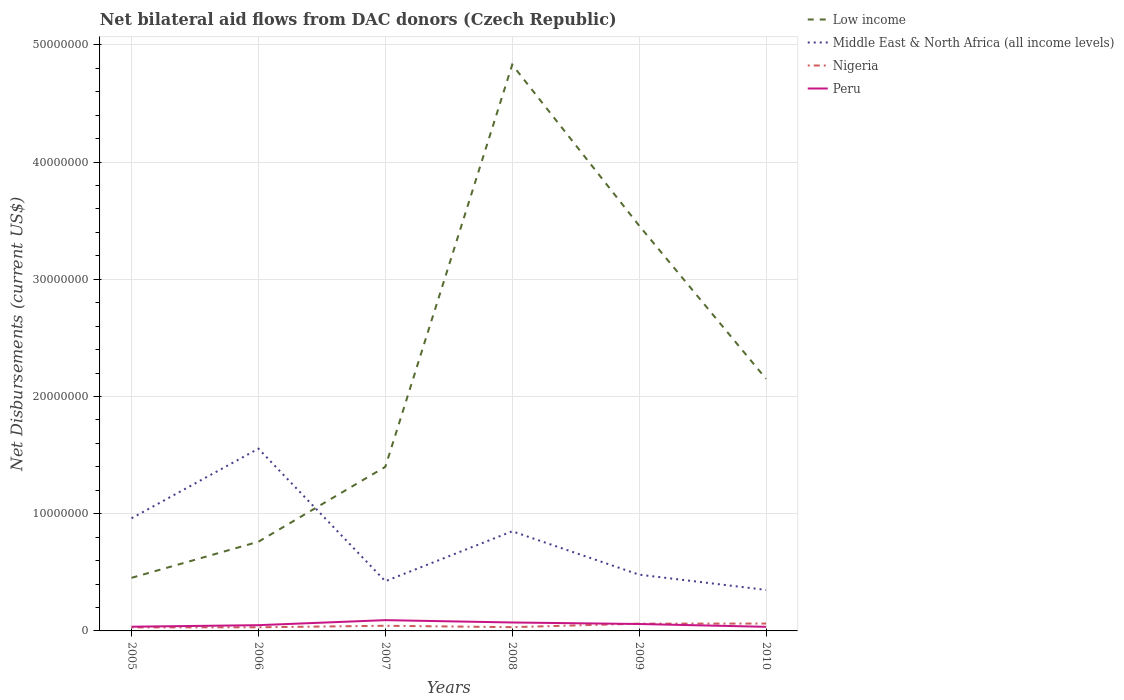How many different coloured lines are there?
Make the answer very short. 4. Is the number of lines equal to the number of legend labels?
Offer a terse response. Yes. Across all years, what is the maximum net bilateral aid flows in Middle East & North Africa (all income levels)?
Provide a short and direct response. 3.50e+06. In which year was the net bilateral aid flows in Peru maximum?
Your response must be concise. 2010. What is the total net bilateral aid flows in Peru in the graph?
Give a very brief answer. 5.70e+05. What is the difference between the highest and the second highest net bilateral aid flows in Low income?
Keep it short and to the point. 4.38e+07. What is the difference between the highest and the lowest net bilateral aid flows in Middle East & North Africa (all income levels)?
Provide a short and direct response. 3. Is the net bilateral aid flows in Peru strictly greater than the net bilateral aid flows in Nigeria over the years?
Offer a very short reply. No. Are the values on the major ticks of Y-axis written in scientific E-notation?
Your answer should be very brief. No. How many legend labels are there?
Ensure brevity in your answer.  4. How are the legend labels stacked?
Your response must be concise. Vertical. What is the title of the graph?
Offer a terse response. Net bilateral aid flows from DAC donors (Czech Republic). What is the label or title of the X-axis?
Provide a short and direct response. Years. What is the label or title of the Y-axis?
Your answer should be compact. Net Disbursements (current US$). What is the Net Disbursements (current US$) of Low income in 2005?
Offer a very short reply. 4.53e+06. What is the Net Disbursements (current US$) of Middle East & North Africa (all income levels) in 2005?
Make the answer very short. 9.61e+06. What is the Net Disbursements (current US$) in Peru in 2005?
Provide a short and direct response. 3.60e+05. What is the Net Disbursements (current US$) in Low income in 2006?
Provide a short and direct response. 7.61e+06. What is the Net Disbursements (current US$) of Middle East & North Africa (all income levels) in 2006?
Provide a succinct answer. 1.56e+07. What is the Net Disbursements (current US$) in Peru in 2006?
Offer a terse response. 4.90e+05. What is the Net Disbursements (current US$) of Low income in 2007?
Your answer should be compact. 1.40e+07. What is the Net Disbursements (current US$) of Middle East & North Africa (all income levels) in 2007?
Give a very brief answer. 4.24e+06. What is the Net Disbursements (current US$) in Nigeria in 2007?
Provide a succinct answer. 4.40e+05. What is the Net Disbursements (current US$) in Peru in 2007?
Your answer should be very brief. 9.20e+05. What is the Net Disbursements (current US$) of Low income in 2008?
Provide a short and direct response. 4.83e+07. What is the Net Disbursements (current US$) of Middle East & North Africa (all income levels) in 2008?
Offer a very short reply. 8.50e+06. What is the Net Disbursements (current US$) in Nigeria in 2008?
Keep it short and to the point. 3.20e+05. What is the Net Disbursements (current US$) in Peru in 2008?
Your response must be concise. 7.20e+05. What is the Net Disbursements (current US$) of Low income in 2009?
Provide a succinct answer. 3.46e+07. What is the Net Disbursements (current US$) in Middle East & North Africa (all income levels) in 2009?
Make the answer very short. 4.80e+06. What is the Net Disbursements (current US$) in Nigeria in 2009?
Offer a terse response. 6.20e+05. What is the Net Disbursements (current US$) in Peru in 2009?
Your answer should be compact. 5.90e+05. What is the Net Disbursements (current US$) in Low income in 2010?
Ensure brevity in your answer.  2.15e+07. What is the Net Disbursements (current US$) in Middle East & North Africa (all income levels) in 2010?
Your answer should be very brief. 3.50e+06. What is the Net Disbursements (current US$) in Nigeria in 2010?
Give a very brief answer. 6.30e+05. Across all years, what is the maximum Net Disbursements (current US$) of Low income?
Provide a short and direct response. 4.83e+07. Across all years, what is the maximum Net Disbursements (current US$) in Middle East & North Africa (all income levels)?
Your response must be concise. 1.56e+07. Across all years, what is the maximum Net Disbursements (current US$) in Nigeria?
Offer a terse response. 6.30e+05. Across all years, what is the maximum Net Disbursements (current US$) of Peru?
Your response must be concise. 9.20e+05. Across all years, what is the minimum Net Disbursements (current US$) of Low income?
Give a very brief answer. 4.53e+06. Across all years, what is the minimum Net Disbursements (current US$) of Middle East & North Africa (all income levels)?
Offer a very short reply. 3.50e+06. Across all years, what is the minimum Net Disbursements (current US$) of Nigeria?
Offer a terse response. 3.00e+05. Across all years, what is the minimum Net Disbursements (current US$) in Peru?
Keep it short and to the point. 3.50e+05. What is the total Net Disbursements (current US$) in Low income in the graph?
Your response must be concise. 1.31e+08. What is the total Net Disbursements (current US$) in Middle East & North Africa (all income levels) in the graph?
Your response must be concise. 4.62e+07. What is the total Net Disbursements (current US$) of Nigeria in the graph?
Provide a succinct answer. 2.62e+06. What is the total Net Disbursements (current US$) in Peru in the graph?
Provide a short and direct response. 3.43e+06. What is the difference between the Net Disbursements (current US$) in Low income in 2005 and that in 2006?
Provide a succinct answer. -3.08e+06. What is the difference between the Net Disbursements (current US$) in Middle East & North Africa (all income levels) in 2005 and that in 2006?
Make the answer very short. -5.94e+06. What is the difference between the Net Disbursements (current US$) in Nigeria in 2005 and that in 2006?
Make the answer very short. -10000. What is the difference between the Net Disbursements (current US$) in Low income in 2005 and that in 2007?
Offer a terse response. -9.47e+06. What is the difference between the Net Disbursements (current US$) of Middle East & North Africa (all income levels) in 2005 and that in 2007?
Make the answer very short. 5.37e+06. What is the difference between the Net Disbursements (current US$) of Peru in 2005 and that in 2007?
Provide a succinct answer. -5.60e+05. What is the difference between the Net Disbursements (current US$) of Low income in 2005 and that in 2008?
Give a very brief answer. -4.38e+07. What is the difference between the Net Disbursements (current US$) of Middle East & North Africa (all income levels) in 2005 and that in 2008?
Your response must be concise. 1.11e+06. What is the difference between the Net Disbursements (current US$) in Nigeria in 2005 and that in 2008?
Make the answer very short. -2.00e+04. What is the difference between the Net Disbursements (current US$) of Peru in 2005 and that in 2008?
Make the answer very short. -3.60e+05. What is the difference between the Net Disbursements (current US$) in Low income in 2005 and that in 2009?
Your answer should be compact. -3.00e+07. What is the difference between the Net Disbursements (current US$) of Middle East & North Africa (all income levels) in 2005 and that in 2009?
Your answer should be compact. 4.81e+06. What is the difference between the Net Disbursements (current US$) in Nigeria in 2005 and that in 2009?
Provide a succinct answer. -3.20e+05. What is the difference between the Net Disbursements (current US$) of Peru in 2005 and that in 2009?
Offer a terse response. -2.30e+05. What is the difference between the Net Disbursements (current US$) in Low income in 2005 and that in 2010?
Give a very brief answer. -1.70e+07. What is the difference between the Net Disbursements (current US$) of Middle East & North Africa (all income levels) in 2005 and that in 2010?
Ensure brevity in your answer.  6.11e+06. What is the difference between the Net Disbursements (current US$) of Nigeria in 2005 and that in 2010?
Offer a very short reply. -3.30e+05. What is the difference between the Net Disbursements (current US$) of Low income in 2006 and that in 2007?
Your answer should be very brief. -6.39e+06. What is the difference between the Net Disbursements (current US$) of Middle East & North Africa (all income levels) in 2006 and that in 2007?
Your answer should be very brief. 1.13e+07. What is the difference between the Net Disbursements (current US$) in Peru in 2006 and that in 2007?
Make the answer very short. -4.30e+05. What is the difference between the Net Disbursements (current US$) of Low income in 2006 and that in 2008?
Provide a short and direct response. -4.07e+07. What is the difference between the Net Disbursements (current US$) in Middle East & North Africa (all income levels) in 2006 and that in 2008?
Give a very brief answer. 7.05e+06. What is the difference between the Net Disbursements (current US$) in Nigeria in 2006 and that in 2008?
Give a very brief answer. -10000. What is the difference between the Net Disbursements (current US$) in Peru in 2006 and that in 2008?
Your answer should be very brief. -2.30e+05. What is the difference between the Net Disbursements (current US$) of Low income in 2006 and that in 2009?
Offer a very short reply. -2.70e+07. What is the difference between the Net Disbursements (current US$) of Middle East & North Africa (all income levels) in 2006 and that in 2009?
Your answer should be compact. 1.08e+07. What is the difference between the Net Disbursements (current US$) of Nigeria in 2006 and that in 2009?
Give a very brief answer. -3.10e+05. What is the difference between the Net Disbursements (current US$) in Peru in 2006 and that in 2009?
Give a very brief answer. -1.00e+05. What is the difference between the Net Disbursements (current US$) of Low income in 2006 and that in 2010?
Offer a terse response. -1.39e+07. What is the difference between the Net Disbursements (current US$) of Middle East & North Africa (all income levels) in 2006 and that in 2010?
Ensure brevity in your answer.  1.20e+07. What is the difference between the Net Disbursements (current US$) in Nigeria in 2006 and that in 2010?
Offer a terse response. -3.20e+05. What is the difference between the Net Disbursements (current US$) in Peru in 2006 and that in 2010?
Give a very brief answer. 1.40e+05. What is the difference between the Net Disbursements (current US$) of Low income in 2007 and that in 2008?
Offer a terse response. -3.43e+07. What is the difference between the Net Disbursements (current US$) of Middle East & North Africa (all income levels) in 2007 and that in 2008?
Your answer should be compact. -4.26e+06. What is the difference between the Net Disbursements (current US$) of Peru in 2007 and that in 2008?
Provide a succinct answer. 2.00e+05. What is the difference between the Net Disbursements (current US$) of Low income in 2007 and that in 2009?
Your answer should be compact. -2.06e+07. What is the difference between the Net Disbursements (current US$) of Middle East & North Africa (all income levels) in 2007 and that in 2009?
Keep it short and to the point. -5.60e+05. What is the difference between the Net Disbursements (current US$) of Low income in 2007 and that in 2010?
Your response must be concise. -7.51e+06. What is the difference between the Net Disbursements (current US$) in Middle East & North Africa (all income levels) in 2007 and that in 2010?
Give a very brief answer. 7.40e+05. What is the difference between the Net Disbursements (current US$) of Peru in 2007 and that in 2010?
Your answer should be very brief. 5.70e+05. What is the difference between the Net Disbursements (current US$) of Low income in 2008 and that in 2009?
Give a very brief answer. 1.37e+07. What is the difference between the Net Disbursements (current US$) of Middle East & North Africa (all income levels) in 2008 and that in 2009?
Provide a short and direct response. 3.70e+06. What is the difference between the Net Disbursements (current US$) in Peru in 2008 and that in 2009?
Provide a short and direct response. 1.30e+05. What is the difference between the Net Disbursements (current US$) of Low income in 2008 and that in 2010?
Your response must be concise. 2.68e+07. What is the difference between the Net Disbursements (current US$) of Nigeria in 2008 and that in 2010?
Offer a terse response. -3.10e+05. What is the difference between the Net Disbursements (current US$) of Low income in 2009 and that in 2010?
Provide a short and direct response. 1.31e+07. What is the difference between the Net Disbursements (current US$) in Middle East & North Africa (all income levels) in 2009 and that in 2010?
Your answer should be very brief. 1.30e+06. What is the difference between the Net Disbursements (current US$) in Nigeria in 2009 and that in 2010?
Give a very brief answer. -10000. What is the difference between the Net Disbursements (current US$) of Low income in 2005 and the Net Disbursements (current US$) of Middle East & North Africa (all income levels) in 2006?
Provide a succinct answer. -1.10e+07. What is the difference between the Net Disbursements (current US$) of Low income in 2005 and the Net Disbursements (current US$) of Nigeria in 2006?
Provide a succinct answer. 4.22e+06. What is the difference between the Net Disbursements (current US$) of Low income in 2005 and the Net Disbursements (current US$) of Peru in 2006?
Offer a terse response. 4.04e+06. What is the difference between the Net Disbursements (current US$) of Middle East & North Africa (all income levels) in 2005 and the Net Disbursements (current US$) of Nigeria in 2006?
Offer a terse response. 9.30e+06. What is the difference between the Net Disbursements (current US$) in Middle East & North Africa (all income levels) in 2005 and the Net Disbursements (current US$) in Peru in 2006?
Ensure brevity in your answer.  9.12e+06. What is the difference between the Net Disbursements (current US$) of Low income in 2005 and the Net Disbursements (current US$) of Nigeria in 2007?
Give a very brief answer. 4.09e+06. What is the difference between the Net Disbursements (current US$) in Low income in 2005 and the Net Disbursements (current US$) in Peru in 2007?
Keep it short and to the point. 3.61e+06. What is the difference between the Net Disbursements (current US$) in Middle East & North Africa (all income levels) in 2005 and the Net Disbursements (current US$) in Nigeria in 2007?
Keep it short and to the point. 9.17e+06. What is the difference between the Net Disbursements (current US$) of Middle East & North Africa (all income levels) in 2005 and the Net Disbursements (current US$) of Peru in 2007?
Your answer should be very brief. 8.69e+06. What is the difference between the Net Disbursements (current US$) in Nigeria in 2005 and the Net Disbursements (current US$) in Peru in 2007?
Your response must be concise. -6.20e+05. What is the difference between the Net Disbursements (current US$) in Low income in 2005 and the Net Disbursements (current US$) in Middle East & North Africa (all income levels) in 2008?
Make the answer very short. -3.97e+06. What is the difference between the Net Disbursements (current US$) in Low income in 2005 and the Net Disbursements (current US$) in Nigeria in 2008?
Offer a very short reply. 4.21e+06. What is the difference between the Net Disbursements (current US$) of Low income in 2005 and the Net Disbursements (current US$) of Peru in 2008?
Your answer should be compact. 3.81e+06. What is the difference between the Net Disbursements (current US$) of Middle East & North Africa (all income levels) in 2005 and the Net Disbursements (current US$) of Nigeria in 2008?
Make the answer very short. 9.29e+06. What is the difference between the Net Disbursements (current US$) in Middle East & North Africa (all income levels) in 2005 and the Net Disbursements (current US$) in Peru in 2008?
Keep it short and to the point. 8.89e+06. What is the difference between the Net Disbursements (current US$) of Nigeria in 2005 and the Net Disbursements (current US$) of Peru in 2008?
Provide a short and direct response. -4.20e+05. What is the difference between the Net Disbursements (current US$) in Low income in 2005 and the Net Disbursements (current US$) in Nigeria in 2009?
Ensure brevity in your answer.  3.91e+06. What is the difference between the Net Disbursements (current US$) of Low income in 2005 and the Net Disbursements (current US$) of Peru in 2009?
Offer a terse response. 3.94e+06. What is the difference between the Net Disbursements (current US$) in Middle East & North Africa (all income levels) in 2005 and the Net Disbursements (current US$) in Nigeria in 2009?
Provide a succinct answer. 8.99e+06. What is the difference between the Net Disbursements (current US$) in Middle East & North Africa (all income levels) in 2005 and the Net Disbursements (current US$) in Peru in 2009?
Make the answer very short. 9.02e+06. What is the difference between the Net Disbursements (current US$) of Low income in 2005 and the Net Disbursements (current US$) of Middle East & North Africa (all income levels) in 2010?
Provide a short and direct response. 1.03e+06. What is the difference between the Net Disbursements (current US$) of Low income in 2005 and the Net Disbursements (current US$) of Nigeria in 2010?
Provide a short and direct response. 3.90e+06. What is the difference between the Net Disbursements (current US$) of Low income in 2005 and the Net Disbursements (current US$) of Peru in 2010?
Your answer should be very brief. 4.18e+06. What is the difference between the Net Disbursements (current US$) in Middle East & North Africa (all income levels) in 2005 and the Net Disbursements (current US$) in Nigeria in 2010?
Offer a very short reply. 8.98e+06. What is the difference between the Net Disbursements (current US$) of Middle East & North Africa (all income levels) in 2005 and the Net Disbursements (current US$) of Peru in 2010?
Give a very brief answer. 9.26e+06. What is the difference between the Net Disbursements (current US$) in Nigeria in 2005 and the Net Disbursements (current US$) in Peru in 2010?
Make the answer very short. -5.00e+04. What is the difference between the Net Disbursements (current US$) in Low income in 2006 and the Net Disbursements (current US$) in Middle East & North Africa (all income levels) in 2007?
Your answer should be very brief. 3.37e+06. What is the difference between the Net Disbursements (current US$) in Low income in 2006 and the Net Disbursements (current US$) in Nigeria in 2007?
Your answer should be very brief. 7.17e+06. What is the difference between the Net Disbursements (current US$) in Low income in 2006 and the Net Disbursements (current US$) in Peru in 2007?
Ensure brevity in your answer.  6.69e+06. What is the difference between the Net Disbursements (current US$) in Middle East & North Africa (all income levels) in 2006 and the Net Disbursements (current US$) in Nigeria in 2007?
Offer a very short reply. 1.51e+07. What is the difference between the Net Disbursements (current US$) in Middle East & North Africa (all income levels) in 2006 and the Net Disbursements (current US$) in Peru in 2007?
Make the answer very short. 1.46e+07. What is the difference between the Net Disbursements (current US$) in Nigeria in 2006 and the Net Disbursements (current US$) in Peru in 2007?
Make the answer very short. -6.10e+05. What is the difference between the Net Disbursements (current US$) in Low income in 2006 and the Net Disbursements (current US$) in Middle East & North Africa (all income levels) in 2008?
Provide a succinct answer. -8.90e+05. What is the difference between the Net Disbursements (current US$) in Low income in 2006 and the Net Disbursements (current US$) in Nigeria in 2008?
Offer a very short reply. 7.29e+06. What is the difference between the Net Disbursements (current US$) in Low income in 2006 and the Net Disbursements (current US$) in Peru in 2008?
Your answer should be compact. 6.89e+06. What is the difference between the Net Disbursements (current US$) of Middle East & North Africa (all income levels) in 2006 and the Net Disbursements (current US$) of Nigeria in 2008?
Make the answer very short. 1.52e+07. What is the difference between the Net Disbursements (current US$) of Middle East & North Africa (all income levels) in 2006 and the Net Disbursements (current US$) of Peru in 2008?
Your answer should be compact. 1.48e+07. What is the difference between the Net Disbursements (current US$) of Nigeria in 2006 and the Net Disbursements (current US$) of Peru in 2008?
Offer a very short reply. -4.10e+05. What is the difference between the Net Disbursements (current US$) in Low income in 2006 and the Net Disbursements (current US$) in Middle East & North Africa (all income levels) in 2009?
Your answer should be very brief. 2.81e+06. What is the difference between the Net Disbursements (current US$) of Low income in 2006 and the Net Disbursements (current US$) of Nigeria in 2009?
Your response must be concise. 6.99e+06. What is the difference between the Net Disbursements (current US$) in Low income in 2006 and the Net Disbursements (current US$) in Peru in 2009?
Provide a succinct answer. 7.02e+06. What is the difference between the Net Disbursements (current US$) of Middle East & North Africa (all income levels) in 2006 and the Net Disbursements (current US$) of Nigeria in 2009?
Provide a succinct answer. 1.49e+07. What is the difference between the Net Disbursements (current US$) of Middle East & North Africa (all income levels) in 2006 and the Net Disbursements (current US$) of Peru in 2009?
Provide a short and direct response. 1.50e+07. What is the difference between the Net Disbursements (current US$) in Nigeria in 2006 and the Net Disbursements (current US$) in Peru in 2009?
Keep it short and to the point. -2.80e+05. What is the difference between the Net Disbursements (current US$) in Low income in 2006 and the Net Disbursements (current US$) in Middle East & North Africa (all income levels) in 2010?
Provide a short and direct response. 4.11e+06. What is the difference between the Net Disbursements (current US$) in Low income in 2006 and the Net Disbursements (current US$) in Nigeria in 2010?
Your response must be concise. 6.98e+06. What is the difference between the Net Disbursements (current US$) in Low income in 2006 and the Net Disbursements (current US$) in Peru in 2010?
Keep it short and to the point. 7.26e+06. What is the difference between the Net Disbursements (current US$) in Middle East & North Africa (all income levels) in 2006 and the Net Disbursements (current US$) in Nigeria in 2010?
Your response must be concise. 1.49e+07. What is the difference between the Net Disbursements (current US$) in Middle East & North Africa (all income levels) in 2006 and the Net Disbursements (current US$) in Peru in 2010?
Your response must be concise. 1.52e+07. What is the difference between the Net Disbursements (current US$) in Low income in 2007 and the Net Disbursements (current US$) in Middle East & North Africa (all income levels) in 2008?
Your answer should be very brief. 5.50e+06. What is the difference between the Net Disbursements (current US$) in Low income in 2007 and the Net Disbursements (current US$) in Nigeria in 2008?
Make the answer very short. 1.37e+07. What is the difference between the Net Disbursements (current US$) in Low income in 2007 and the Net Disbursements (current US$) in Peru in 2008?
Provide a succinct answer. 1.33e+07. What is the difference between the Net Disbursements (current US$) in Middle East & North Africa (all income levels) in 2007 and the Net Disbursements (current US$) in Nigeria in 2008?
Your response must be concise. 3.92e+06. What is the difference between the Net Disbursements (current US$) of Middle East & North Africa (all income levels) in 2007 and the Net Disbursements (current US$) of Peru in 2008?
Your response must be concise. 3.52e+06. What is the difference between the Net Disbursements (current US$) in Nigeria in 2007 and the Net Disbursements (current US$) in Peru in 2008?
Your answer should be very brief. -2.80e+05. What is the difference between the Net Disbursements (current US$) in Low income in 2007 and the Net Disbursements (current US$) in Middle East & North Africa (all income levels) in 2009?
Keep it short and to the point. 9.20e+06. What is the difference between the Net Disbursements (current US$) of Low income in 2007 and the Net Disbursements (current US$) of Nigeria in 2009?
Your response must be concise. 1.34e+07. What is the difference between the Net Disbursements (current US$) of Low income in 2007 and the Net Disbursements (current US$) of Peru in 2009?
Ensure brevity in your answer.  1.34e+07. What is the difference between the Net Disbursements (current US$) of Middle East & North Africa (all income levels) in 2007 and the Net Disbursements (current US$) of Nigeria in 2009?
Provide a short and direct response. 3.62e+06. What is the difference between the Net Disbursements (current US$) in Middle East & North Africa (all income levels) in 2007 and the Net Disbursements (current US$) in Peru in 2009?
Your answer should be compact. 3.65e+06. What is the difference between the Net Disbursements (current US$) in Nigeria in 2007 and the Net Disbursements (current US$) in Peru in 2009?
Keep it short and to the point. -1.50e+05. What is the difference between the Net Disbursements (current US$) in Low income in 2007 and the Net Disbursements (current US$) in Middle East & North Africa (all income levels) in 2010?
Your response must be concise. 1.05e+07. What is the difference between the Net Disbursements (current US$) of Low income in 2007 and the Net Disbursements (current US$) of Nigeria in 2010?
Your answer should be very brief. 1.34e+07. What is the difference between the Net Disbursements (current US$) of Low income in 2007 and the Net Disbursements (current US$) of Peru in 2010?
Make the answer very short. 1.36e+07. What is the difference between the Net Disbursements (current US$) of Middle East & North Africa (all income levels) in 2007 and the Net Disbursements (current US$) of Nigeria in 2010?
Make the answer very short. 3.61e+06. What is the difference between the Net Disbursements (current US$) of Middle East & North Africa (all income levels) in 2007 and the Net Disbursements (current US$) of Peru in 2010?
Provide a short and direct response. 3.89e+06. What is the difference between the Net Disbursements (current US$) in Nigeria in 2007 and the Net Disbursements (current US$) in Peru in 2010?
Offer a terse response. 9.00e+04. What is the difference between the Net Disbursements (current US$) of Low income in 2008 and the Net Disbursements (current US$) of Middle East & North Africa (all income levels) in 2009?
Provide a short and direct response. 4.35e+07. What is the difference between the Net Disbursements (current US$) in Low income in 2008 and the Net Disbursements (current US$) in Nigeria in 2009?
Keep it short and to the point. 4.77e+07. What is the difference between the Net Disbursements (current US$) of Low income in 2008 and the Net Disbursements (current US$) of Peru in 2009?
Give a very brief answer. 4.77e+07. What is the difference between the Net Disbursements (current US$) in Middle East & North Africa (all income levels) in 2008 and the Net Disbursements (current US$) in Nigeria in 2009?
Your response must be concise. 7.88e+06. What is the difference between the Net Disbursements (current US$) of Middle East & North Africa (all income levels) in 2008 and the Net Disbursements (current US$) of Peru in 2009?
Your answer should be compact. 7.91e+06. What is the difference between the Net Disbursements (current US$) in Nigeria in 2008 and the Net Disbursements (current US$) in Peru in 2009?
Give a very brief answer. -2.70e+05. What is the difference between the Net Disbursements (current US$) in Low income in 2008 and the Net Disbursements (current US$) in Middle East & North Africa (all income levels) in 2010?
Your response must be concise. 4.48e+07. What is the difference between the Net Disbursements (current US$) of Low income in 2008 and the Net Disbursements (current US$) of Nigeria in 2010?
Make the answer very short. 4.77e+07. What is the difference between the Net Disbursements (current US$) of Low income in 2008 and the Net Disbursements (current US$) of Peru in 2010?
Offer a terse response. 4.80e+07. What is the difference between the Net Disbursements (current US$) in Middle East & North Africa (all income levels) in 2008 and the Net Disbursements (current US$) in Nigeria in 2010?
Keep it short and to the point. 7.87e+06. What is the difference between the Net Disbursements (current US$) of Middle East & North Africa (all income levels) in 2008 and the Net Disbursements (current US$) of Peru in 2010?
Your response must be concise. 8.15e+06. What is the difference between the Net Disbursements (current US$) of Low income in 2009 and the Net Disbursements (current US$) of Middle East & North Africa (all income levels) in 2010?
Provide a short and direct response. 3.11e+07. What is the difference between the Net Disbursements (current US$) in Low income in 2009 and the Net Disbursements (current US$) in Nigeria in 2010?
Give a very brief answer. 3.40e+07. What is the difference between the Net Disbursements (current US$) of Low income in 2009 and the Net Disbursements (current US$) of Peru in 2010?
Keep it short and to the point. 3.42e+07. What is the difference between the Net Disbursements (current US$) of Middle East & North Africa (all income levels) in 2009 and the Net Disbursements (current US$) of Nigeria in 2010?
Provide a short and direct response. 4.17e+06. What is the difference between the Net Disbursements (current US$) of Middle East & North Africa (all income levels) in 2009 and the Net Disbursements (current US$) of Peru in 2010?
Give a very brief answer. 4.45e+06. What is the average Net Disbursements (current US$) in Low income per year?
Ensure brevity in your answer.  2.18e+07. What is the average Net Disbursements (current US$) in Middle East & North Africa (all income levels) per year?
Offer a very short reply. 7.70e+06. What is the average Net Disbursements (current US$) in Nigeria per year?
Keep it short and to the point. 4.37e+05. What is the average Net Disbursements (current US$) in Peru per year?
Ensure brevity in your answer.  5.72e+05. In the year 2005, what is the difference between the Net Disbursements (current US$) of Low income and Net Disbursements (current US$) of Middle East & North Africa (all income levels)?
Keep it short and to the point. -5.08e+06. In the year 2005, what is the difference between the Net Disbursements (current US$) in Low income and Net Disbursements (current US$) in Nigeria?
Offer a terse response. 4.23e+06. In the year 2005, what is the difference between the Net Disbursements (current US$) in Low income and Net Disbursements (current US$) in Peru?
Provide a short and direct response. 4.17e+06. In the year 2005, what is the difference between the Net Disbursements (current US$) of Middle East & North Africa (all income levels) and Net Disbursements (current US$) of Nigeria?
Provide a succinct answer. 9.31e+06. In the year 2005, what is the difference between the Net Disbursements (current US$) in Middle East & North Africa (all income levels) and Net Disbursements (current US$) in Peru?
Your answer should be compact. 9.25e+06. In the year 2005, what is the difference between the Net Disbursements (current US$) in Nigeria and Net Disbursements (current US$) in Peru?
Give a very brief answer. -6.00e+04. In the year 2006, what is the difference between the Net Disbursements (current US$) of Low income and Net Disbursements (current US$) of Middle East & North Africa (all income levels)?
Provide a short and direct response. -7.94e+06. In the year 2006, what is the difference between the Net Disbursements (current US$) in Low income and Net Disbursements (current US$) in Nigeria?
Make the answer very short. 7.30e+06. In the year 2006, what is the difference between the Net Disbursements (current US$) in Low income and Net Disbursements (current US$) in Peru?
Offer a very short reply. 7.12e+06. In the year 2006, what is the difference between the Net Disbursements (current US$) in Middle East & North Africa (all income levels) and Net Disbursements (current US$) in Nigeria?
Provide a short and direct response. 1.52e+07. In the year 2006, what is the difference between the Net Disbursements (current US$) in Middle East & North Africa (all income levels) and Net Disbursements (current US$) in Peru?
Give a very brief answer. 1.51e+07. In the year 2007, what is the difference between the Net Disbursements (current US$) of Low income and Net Disbursements (current US$) of Middle East & North Africa (all income levels)?
Offer a very short reply. 9.76e+06. In the year 2007, what is the difference between the Net Disbursements (current US$) in Low income and Net Disbursements (current US$) in Nigeria?
Provide a short and direct response. 1.36e+07. In the year 2007, what is the difference between the Net Disbursements (current US$) of Low income and Net Disbursements (current US$) of Peru?
Make the answer very short. 1.31e+07. In the year 2007, what is the difference between the Net Disbursements (current US$) in Middle East & North Africa (all income levels) and Net Disbursements (current US$) in Nigeria?
Your response must be concise. 3.80e+06. In the year 2007, what is the difference between the Net Disbursements (current US$) in Middle East & North Africa (all income levels) and Net Disbursements (current US$) in Peru?
Your answer should be very brief. 3.32e+06. In the year 2007, what is the difference between the Net Disbursements (current US$) of Nigeria and Net Disbursements (current US$) of Peru?
Offer a terse response. -4.80e+05. In the year 2008, what is the difference between the Net Disbursements (current US$) in Low income and Net Disbursements (current US$) in Middle East & North Africa (all income levels)?
Provide a succinct answer. 3.98e+07. In the year 2008, what is the difference between the Net Disbursements (current US$) in Low income and Net Disbursements (current US$) in Nigeria?
Keep it short and to the point. 4.80e+07. In the year 2008, what is the difference between the Net Disbursements (current US$) of Low income and Net Disbursements (current US$) of Peru?
Your response must be concise. 4.76e+07. In the year 2008, what is the difference between the Net Disbursements (current US$) in Middle East & North Africa (all income levels) and Net Disbursements (current US$) in Nigeria?
Provide a succinct answer. 8.18e+06. In the year 2008, what is the difference between the Net Disbursements (current US$) in Middle East & North Africa (all income levels) and Net Disbursements (current US$) in Peru?
Keep it short and to the point. 7.78e+06. In the year 2008, what is the difference between the Net Disbursements (current US$) in Nigeria and Net Disbursements (current US$) in Peru?
Give a very brief answer. -4.00e+05. In the year 2009, what is the difference between the Net Disbursements (current US$) in Low income and Net Disbursements (current US$) in Middle East & North Africa (all income levels)?
Your answer should be compact. 2.98e+07. In the year 2009, what is the difference between the Net Disbursements (current US$) in Low income and Net Disbursements (current US$) in Nigeria?
Your response must be concise. 3.40e+07. In the year 2009, what is the difference between the Net Disbursements (current US$) in Low income and Net Disbursements (current US$) in Peru?
Keep it short and to the point. 3.40e+07. In the year 2009, what is the difference between the Net Disbursements (current US$) of Middle East & North Africa (all income levels) and Net Disbursements (current US$) of Nigeria?
Your response must be concise. 4.18e+06. In the year 2009, what is the difference between the Net Disbursements (current US$) in Middle East & North Africa (all income levels) and Net Disbursements (current US$) in Peru?
Provide a succinct answer. 4.21e+06. In the year 2010, what is the difference between the Net Disbursements (current US$) of Low income and Net Disbursements (current US$) of Middle East & North Africa (all income levels)?
Provide a succinct answer. 1.80e+07. In the year 2010, what is the difference between the Net Disbursements (current US$) in Low income and Net Disbursements (current US$) in Nigeria?
Offer a terse response. 2.09e+07. In the year 2010, what is the difference between the Net Disbursements (current US$) of Low income and Net Disbursements (current US$) of Peru?
Keep it short and to the point. 2.12e+07. In the year 2010, what is the difference between the Net Disbursements (current US$) of Middle East & North Africa (all income levels) and Net Disbursements (current US$) of Nigeria?
Your answer should be very brief. 2.87e+06. In the year 2010, what is the difference between the Net Disbursements (current US$) of Middle East & North Africa (all income levels) and Net Disbursements (current US$) of Peru?
Ensure brevity in your answer.  3.15e+06. What is the ratio of the Net Disbursements (current US$) of Low income in 2005 to that in 2006?
Make the answer very short. 0.6. What is the ratio of the Net Disbursements (current US$) in Middle East & North Africa (all income levels) in 2005 to that in 2006?
Your response must be concise. 0.62. What is the ratio of the Net Disbursements (current US$) in Peru in 2005 to that in 2006?
Provide a short and direct response. 0.73. What is the ratio of the Net Disbursements (current US$) in Low income in 2005 to that in 2007?
Provide a succinct answer. 0.32. What is the ratio of the Net Disbursements (current US$) of Middle East & North Africa (all income levels) in 2005 to that in 2007?
Offer a very short reply. 2.27. What is the ratio of the Net Disbursements (current US$) of Nigeria in 2005 to that in 2007?
Your response must be concise. 0.68. What is the ratio of the Net Disbursements (current US$) in Peru in 2005 to that in 2007?
Provide a succinct answer. 0.39. What is the ratio of the Net Disbursements (current US$) of Low income in 2005 to that in 2008?
Your answer should be very brief. 0.09. What is the ratio of the Net Disbursements (current US$) of Middle East & North Africa (all income levels) in 2005 to that in 2008?
Provide a succinct answer. 1.13. What is the ratio of the Net Disbursements (current US$) in Low income in 2005 to that in 2009?
Keep it short and to the point. 0.13. What is the ratio of the Net Disbursements (current US$) of Middle East & North Africa (all income levels) in 2005 to that in 2009?
Offer a very short reply. 2. What is the ratio of the Net Disbursements (current US$) of Nigeria in 2005 to that in 2009?
Provide a succinct answer. 0.48. What is the ratio of the Net Disbursements (current US$) in Peru in 2005 to that in 2009?
Offer a very short reply. 0.61. What is the ratio of the Net Disbursements (current US$) of Low income in 2005 to that in 2010?
Your response must be concise. 0.21. What is the ratio of the Net Disbursements (current US$) in Middle East & North Africa (all income levels) in 2005 to that in 2010?
Make the answer very short. 2.75. What is the ratio of the Net Disbursements (current US$) in Nigeria in 2005 to that in 2010?
Your answer should be very brief. 0.48. What is the ratio of the Net Disbursements (current US$) of Peru in 2005 to that in 2010?
Provide a short and direct response. 1.03. What is the ratio of the Net Disbursements (current US$) of Low income in 2006 to that in 2007?
Your response must be concise. 0.54. What is the ratio of the Net Disbursements (current US$) in Middle East & North Africa (all income levels) in 2006 to that in 2007?
Offer a terse response. 3.67. What is the ratio of the Net Disbursements (current US$) in Nigeria in 2006 to that in 2007?
Provide a succinct answer. 0.7. What is the ratio of the Net Disbursements (current US$) in Peru in 2006 to that in 2007?
Give a very brief answer. 0.53. What is the ratio of the Net Disbursements (current US$) in Low income in 2006 to that in 2008?
Ensure brevity in your answer.  0.16. What is the ratio of the Net Disbursements (current US$) in Middle East & North Africa (all income levels) in 2006 to that in 2008?
Provide a succinct answer. 1.83. What is the ratio of the Net Disbursements (current US$) in Nigeria in 2006 to that in 2008?
Provide a short and direct response. 0.97. What is the ratio of the Net Disbursements (current US$) of Peru in 2006 to that in 2008?
Make the answer very short. 0.68. What is the ratio of the Net Disbursements (current US$) in Low income in 2006 to that in 2009?
Your response must be concise. 0.22. What is the ratio of the Net Disbursements (current US$) of Middle East & North Africa (all income levels) in 2006 to that in 2009?
Offer a very short reply. 3.24. What is the ratio of the Net Disbursements (current US$) of Nigeria in 2006 to that in 2009?
Offer a very short reply. 0.5. What is the ratio of the Net Disbursements (current US$) of Peru in 2006 to that in 2009?
Your answer should be compact. 0.83. What is the ratio of the Net Disbursements (current US$) in Low income in 2006 to that in 2010?
Keep it short and to the point. 0.35. What is the ratio of the Net Disbursements (current US$) of Middle East & North Africa (all income levels) in 2006 to that in 2010?
Your answer should be compact. 4.44. What is the ratio of the Net Disbursements (current US$) in Nigeria in 2006 to that in 2010?
Offer a terse response. 0.49. What is the ratio of the Net Disbursements (current US$) in Low income in 2007 to that in 2008?
Keep it short and to the point. 0.29. What is the ratio of the Net Disbursements (current US$) of Middle East & North Africa (all income levels) in 2007 to that in 2008?
Your response must be concise. 0.5. What is the ratio of the Net Disbursements (current US$) of Nigeria in 2007 to that in 2008?
Offer a terse response. 1.38. What is the ratio of the Net Disbursements (current US$) of Peru in 2007 to that in 2008?
Your response must be concise. 1.28. What is the ratio of the Net Disbursements (current US$) of Low income in 2007 to that in 2009?
Provide a succinct answer. 0.4. What is the ratio of the Net Disbursements (current US$) of Middle East & North Africa (all income levels) in 2007 to that in 2009?
Provide a succinct answer. 0.88. What is the ratio of the Net Disbursements (current US$) in Nigeria in 2007 to that in 2009?
Ensure brevity in your answer.  0.71. What is the ratio of the Net Disbursements (current US$) in Peru in 2007 to that in 2009?
Keep it short and to the point. 1.56. What is the ratio of the Net Disbursements (current US$) of Low income in 2007 to that in 2010?
Provide a short and direct response. 0.65. What is the ratio of the Net Disbursements (current US$) in Middle East & North Africa (all income levels) in 2007 to that in 2010?
Your response must be concise. 1.21. What is the ratio of the Net Disbursements (current US$) in Nigeria in 2007 to that in 2010?
Offer a very short reply. 0.7. What is the ratio of the Net Disbursements (current US$) of Peru in 2007 to that in 2010?
Provide a succinct answer. 2.63. What is the ratio of the Net Disbursements (current US$) of Low income in 2008 to that in 2009?
Ensure brevity in your answer.  1.4. What is the ratio of the Net Disbursements (current US$) in Middle East & North Africa (all income levels) in 2008 to that in 2009?
Your answer should be very brief. 1.77. What is the ratio of the Net Disbursements (current US$) of Nigeria in 2008 to that in 2009?
Ensure brevity in your answer.  0.52. What is the ratio of the Net Disbursements (current US$) of Peru in 2008 to that in 2009?
Make the answer very short. 1.22. What is the ratio of the Net Disbursements (current US$) of Low income in 2008 to that in 2010?
Your response must be concise. 2.25. What is the ratio of the Net Disbursements (current US$) of Middle East & North Africa (all income levels) in 2008 to that in 2010?
Offer a terse response. 2.43. What is the ratio of the Net Disbursements (current US$) in Nigeria in 2008 to that in 2010?
Provide a short and direct response. 0.51. What is the ratio of the Net Disbursements (current US$) in Peru in 2008 to that in 2010?
Your response must be concise. 2.06. What is the ratio of the Net Disbursements (current US$) in Low income in 2009 to that in 2010?
Ensure brevity in your answer.  1.61. What is the ratio of the Net Disbursements (current US$) of Middle East & North Africa (all income levels) in 2009 to that in 2010?
Your answer should be very brief. 1.37. What is the ratio of the Net Disbursements (current US$) of Nigeria in 2009 to that in 2010?
Make the answer very short. 0.98. What is the ratio of the Net Disbursements (current US$) in Peru in 2009 to that in 2010?
Your answer should be compact. 1.69. What is the difference between the highest and the second highest Net Disbursements (current US$) in Low income?
Your answer should be compact. 1.37e+07. What is the difference between the highest and the second highest Net Disbursements (current US$) of Middle East & North Africa (all income levels)?
Provide a succinct answer. 5.94e+06. What is the difference between the highest and the second highest Net Disbursements (current US$) of Peru?
Keep it short and to the point. 2.00e+05. What is the difference between the highest and the lowest Net Disbursements (current US$) in Low income?
Your answer should be very brief. 4.38e+07. What is the difference between the highest and the lowest Net Disbursements (current US$) of Middle East & North Africa (all income levels)?
Keep it short and to the point. 1.20e+07. What is the difference between the highest and the lowest Net Disbursements (current US$) in Nigeria?
Ensure brevity in your answer.  3.30e+05. What is the difference between the highest and the lowest Net Disbursements (current US$) of Peru?
Provide a short and direct response. 5.70e+05. 